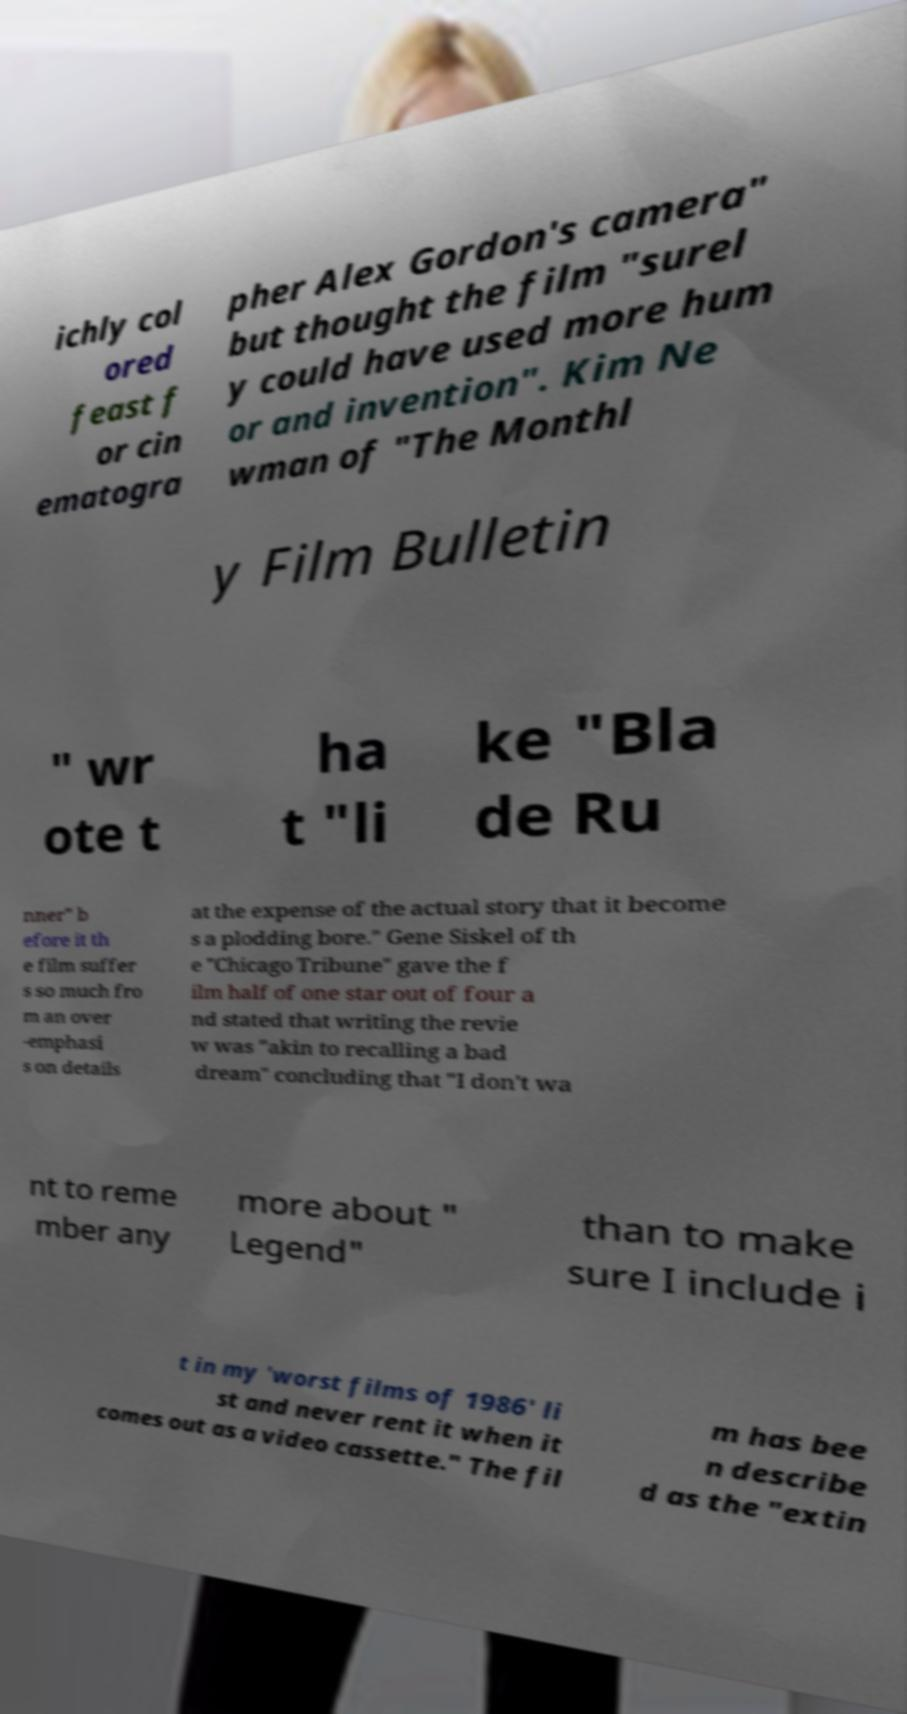For documentation purposes, I need the text within this image transcribed. Could you provide that? ichly col ored feast f or cin ematogra pher Alex Gordon's camera" but thought the film "surel y could have used more hum or and invention". Kim Ne wman of "The Monthl y Film Bulletin " wr ote t ha t "li ke "Bla de Ru nner" b efore it th e film suffer s so much fro m an over -emphasi s on details at the expense of the actual story that it become s a plodding bore." Gene Siskel of th e "Chicago Tribune" gave the f ilm half of one star out of four a nd stated that writing the revie w was "akin to recalling a bad dream" concluding that "I don't wa nt to reme mber any more about " Legend" than to make sure I include i t in my 'worst films of 1986' li st and never rent it when it comes out as a video cassette." The fil m has bee n describe d as the "extin 